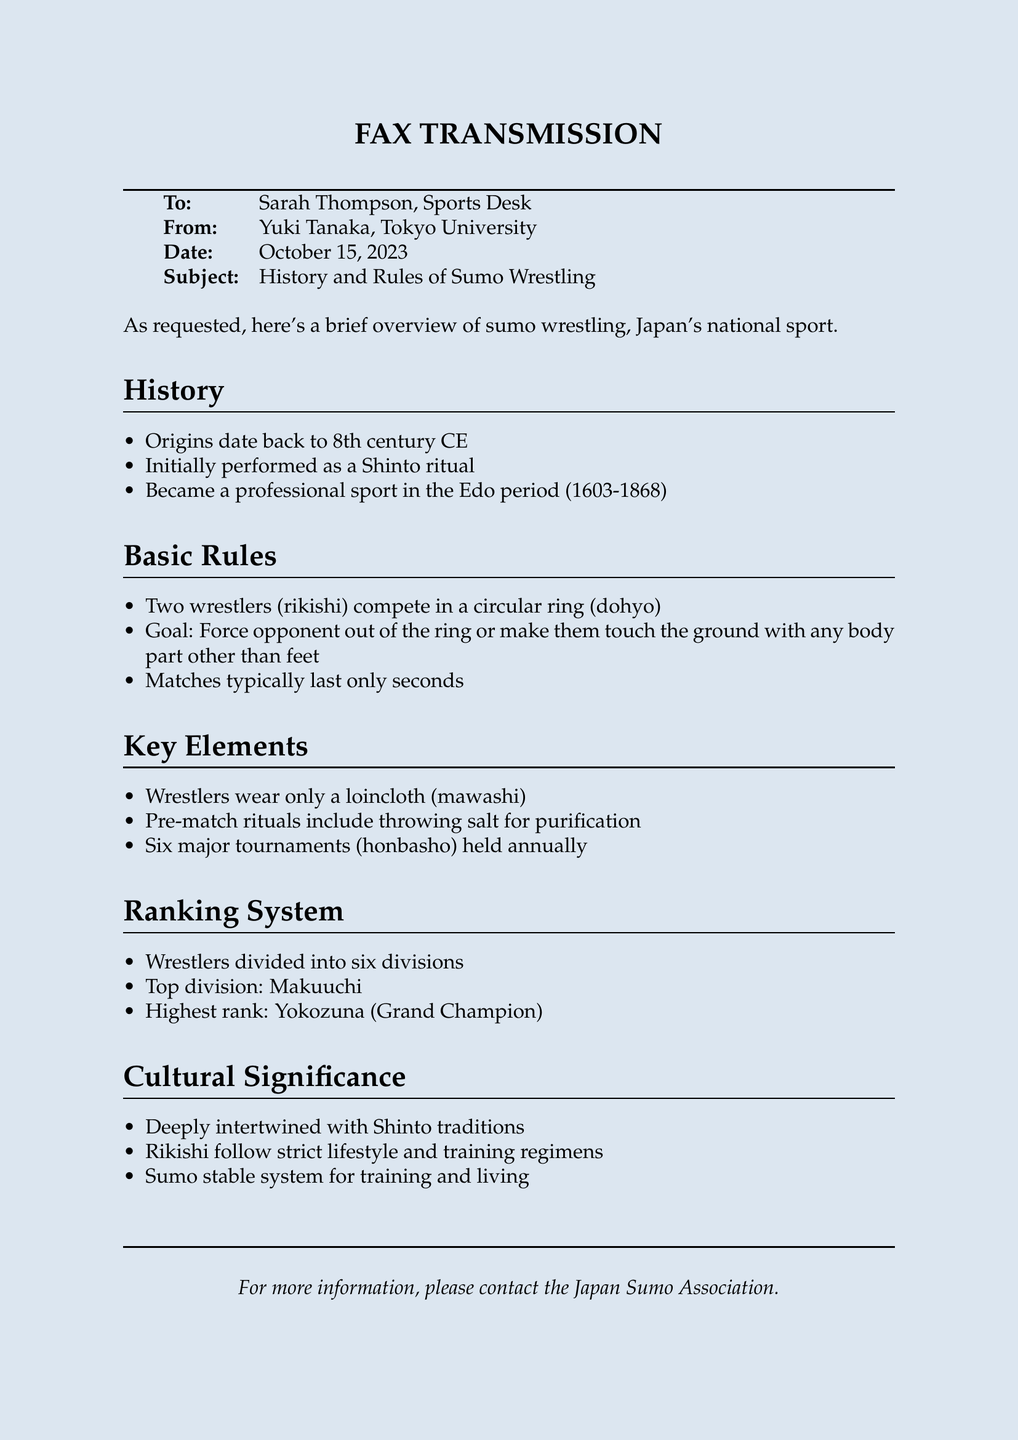What is the subject of the fax? The subject is clearly stated in the header of the document, focusing on the history and rules of the sport.
Answer: History and Rules of Sumo Wrestling Who is the sender of the fax? The sender's name is provided in the document; it is important to know who provided the information.
Answer: Yuki Tanaka In what century did sumo wrestling originate? The history section indicates when sumo wrestling's origins date back to, allowing for precise identification of the timeframe.
Answer: 8th century What is the primary goal in a sumo match? The basic rules section outlines the main objective of the match, serving as a fundamental aspect of the sport.
Answer: Force opponent out of the ring What type of clothing do wrestlers wear? The key elements section specifies what wrestlers wear during matches, which reflects a unique aspect of the sport's culture.
Answer: Loincloth (mawashi) How many major tournaments are held annually? The key elements section mentions the frequency of major tournaments, which is a relevant detail about the sport's calendar.
Answer: Six What is the highest rank a wrestler can achieve? The ranking system section details the hierarchy within sumo wrestling, highlighting the pinnacle of achievement for wrestlers.
Answer: Yokozuna What cultural aspects does sumo wrestling incorporate? The cultural significance section explains the traditions associated with sumo wrestling, showcasing its deep-rooted history in culture.
Answer: Shinto traditions How many divisions are wrestlers divided into? The ranking system section specifies how wrestlers are categorized, providing insight into the sport's structure.
Answer: Six divisions 